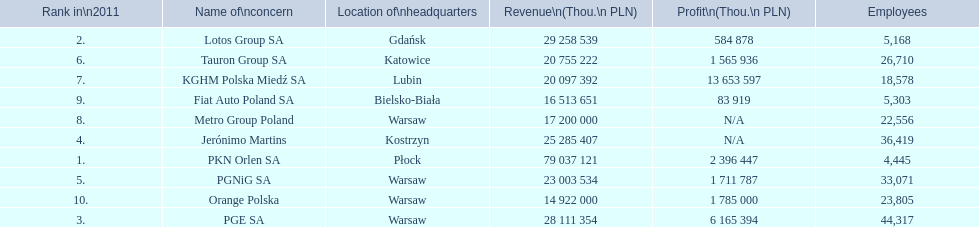What is the difference in employees for rank 1 and rank 3? 39,872 employees. 